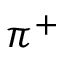<formula> <loc_0><loc_0><loc_500><loc_500>\pi ^ { + }</formula> 